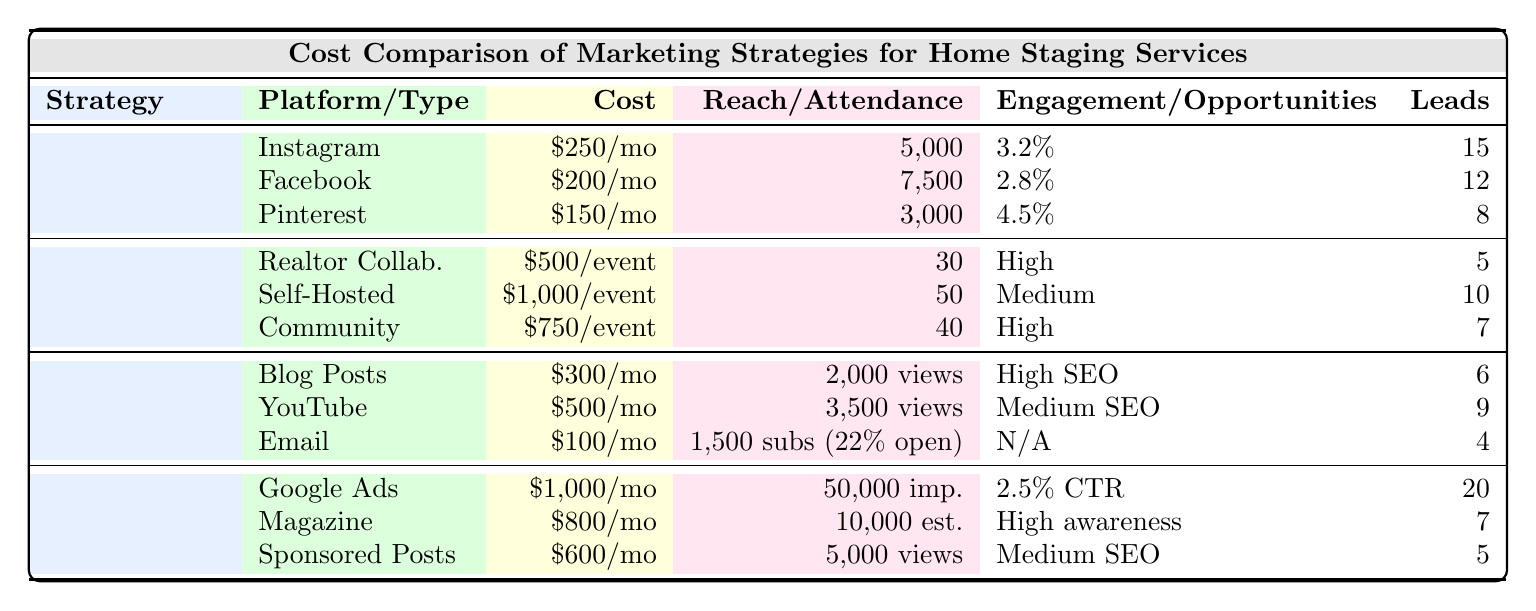What is the monthly cost for Facebook marketing? The table lists Facebook under Social Media, and the Monthly Cost is shown as \$200.
Answer: \$200 Which type of open house event has the highest cost per event? The costs for the open house events are \$500 for Realtor Collaboration, \$1,000 for Self-Hosted Showcase, and \$750 for Community Open House. The highest cost is \$1,000 for Self-Hosted Showcase.
Answer: \$1,000 How many leads does Instagram generate? In the Social Media section, Instagram shows Lead Generation of 15.
Answer: 15 What is the average attendance for community open house events? The Community Open House has an Average Attendance of 40 as shown in the table.
Answer: 40 Which platform has the highest engagement rate? The engagement rates for the platforms are 3.2% for Instagram, 2.8% for Facebook, and 4.5% for Pinterest. The highest engagement rate is 4.5% for Pinterest.
Answer: 4.5% What is the total monthly cost for all social media platforms? Adding the monthly costs: Instagram (\$250) + Facebook (\$200) + Pinterest (\$150) = \$600.
Answer: \$600 Which marketing strategy generates the least leads? In the table, the leads from Content Marketing's Email Newsletter are 4, which is less compared to others.
Answer: 4 Is the SEO impact for Blog Posts high? According to the table, Blog Posts report a High SEO Impact.
Answer: Yes Which method of paid advertising generates the most leads? Google Ads in Paid Advertising generates 20 leads, which is the highest among the listed methods.
Answer: 20 What is the difference in average attendance between the self-hosted showcase and community open house? Self-Hosted Showcase has an Average Attendance of 50, and Community Open House has 40. The difference is 50 - 40 = 10.
Answer: 10 How many total leads does the Paid Advertising strategy generate? Total leads for Paid Advertising are: Google Ads (20) + Local Magazine Ads (7) + Sponsored Blog Posts (5) which equals 32.
Answer: 32 For which platform is the average reach the highest? The average reach values are 5,000 for Instagram, 7,500 for Facebook, and 3,000 for Pinterest, so Facebook has the highest average reach of 7,500.
Answer: 7,500 What is the average monthly cost across all marketing strategies? The total monthly costs are: Social Media (\$600) + Content Marketing (\$900) + Paid Advertising (\$2,400). The average monthly cost is (\$600 + \$900 + \$2,400) / 4 = \$975.
Answer: \$975 Which open house event offers the highest networking opportunities? Both Realtor Collaboration and Community Open House have High networking opportunities, making them the highest in that category.
Answer: Yes Is the engagement rate of Twitter included in the table? Twitter is not mentioned in the table, and therefore no engagement rate is indicated for it.
Answer: No 